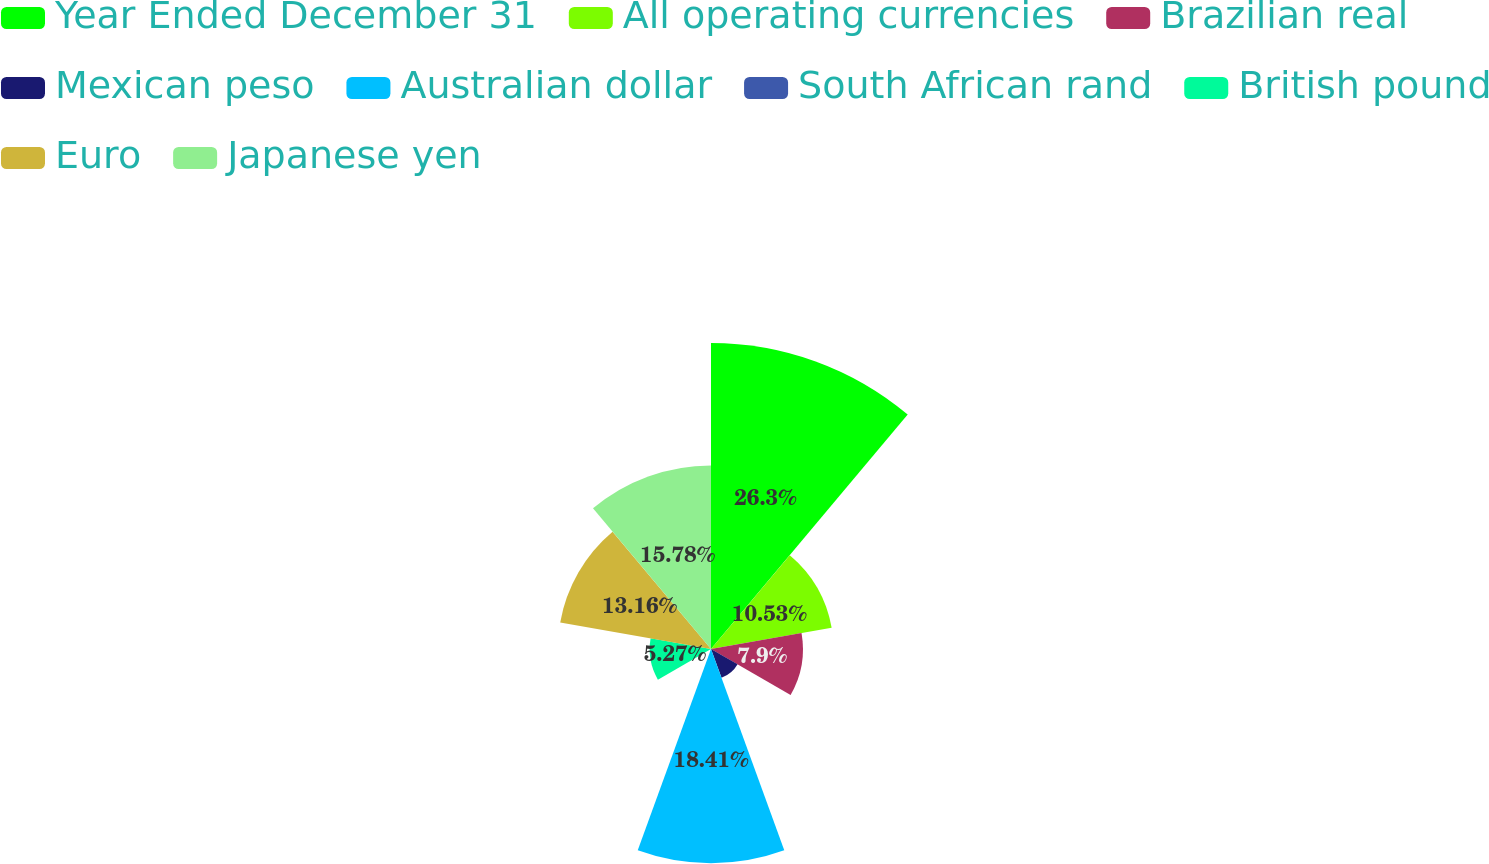Convert chart. <chart><loc_0><loc_0><loc_500><loc_500><pie_chart><fcel>Year Ended December 31<fcel>All operating currencies<fcel>Brazilian real<fcel>Mexican peso<fcel>Australian dollar<fcel>South African rand<fcel>British pound<fcel>Euro<fcel>Japanese yen<nl><fcel>26.3%<fcel>10.53%<fcel>7.9%<fcel>2.64%<fcel>18.41%<fcel>0.01%<fcel>5.27%<fcel>13.16%<fcel>15.78%<nl></chart> 